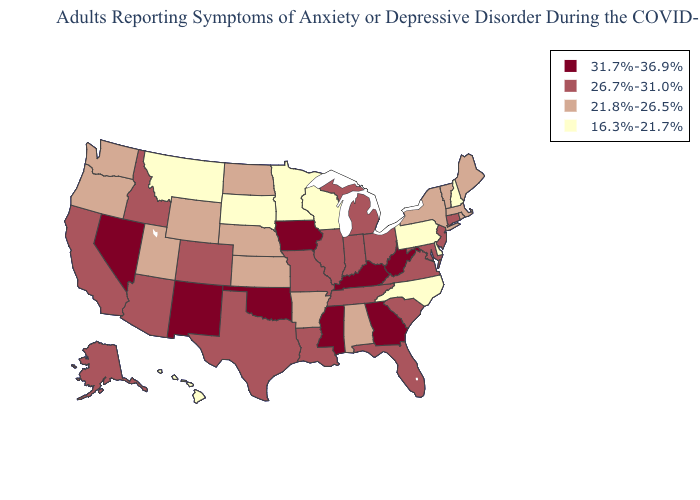Among the states that border Georgia , which have the highest value?
Give a very brief answer. Florida, South Carolina, Tennessee. What is the value of Michigan?
Short answer required. 26.7%-31.0%. Does the first symbol in the legend represent the smallest category?
Be succinct. No. Name the states that have a value in the range 21.8%-26.5%?
Short answer required. Alabama, Arkansas, Kansas, Maine, Massachusetts, Nebraska, New York, North Dakota, Oregon, Rhode Island, Utah, Vermont, Washington, Wyoming. How many symbols are there in the legend?
Quick response, please. 4. Does Alaska have a higher value than Maryland?
Be succinct. No. What is the value of Colorado?
Quick response, please. 26.7%-31.0%. Which states have the highest value in the USA?
Answer briefly. Georgia, Iowa, Kentucky, Mississippi, Nevada, New Mexico, Oklahoma, West Virginia. Does Missouri have the highest value in the MidWest?
Keep it brief. No. Does Minnesota have the lowest value in the USA?
Write a very short answer. Yes. Does the map have missing data?
Concise answer only. No. What is the lowest value in states that border Wyoming?
Write a very short answer. 16.3%-21.7%. What is the value of Alabama?
Keep it brief. 21.8%-26.5%. Name the states that have a value in the range 31.7%-36.9%?
Keep it brief. Georgia, Iowa, Kentucky, Mississippi, Nevada, New Mexico, Oklahoma, West Virginia. 